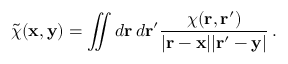Convert formula to latex. <formula><loc_0><loc_0><loc_500><loc_500>\tilde { \chi } ( { x } , { y } ) = \iint d { r } \, d { r ^ { \prime } } \frac { \chi ( { r } , { r ^ { \prime } } ) } { | { r } - { x } | | { r } ^ { \prime } - { y } | } \, .</formula> 